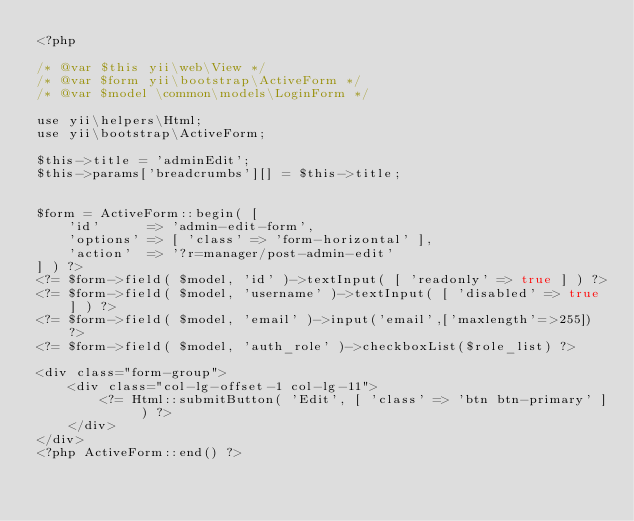<code> <loc_0><loc_0><loc_500><loc_500><_PHP_><?php

/* @var $this yii\web\View */
/* @var $form yii\bootstrap\ActiveForm */
/* @var $model \common\models\LoginForm */

use yii\helpers\Html;
use yii\bootstrap\ActiveForm;

$this->title = 'adminEdit';
$this->params['breadcrumbs'][] = $this->title;


$form = ActiveForm::begin( [
    'id'      => 'admin-edit-form',
    'options' => [ 'class' => 'form-horizontal' ],
    'action'  => '?r=manager/post-admin-edit'
] ) ?>
<?= $form->field( $model, 'id' )->textInput( [ 'readonly' => true ] ) ?>
<?= $form->field( $model, 'username' )->textInput( [ 'disabled' => true ] ) ?>
<?= $form->field( $model, 'email' )->input('email',['maxlength'=>255]) ?>
<?= $form->field( $model, 'auth_role' )->checkboxList($role_list) ?>

<div class="form-group">
    <div class="col-lg-offset-1 col-lg-11">
        <?= Html::submitButton( 'Edit', [ 'class' => 'btn btn-primary' ] ) ?>
    </div>
</div>
<?php ActiveForm::end() ?></code> 